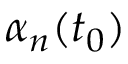<formula> <loc_0><loc_0><loc_500><loc_500>\alpha _ { n } ( t _ { 0 } )</formula> 